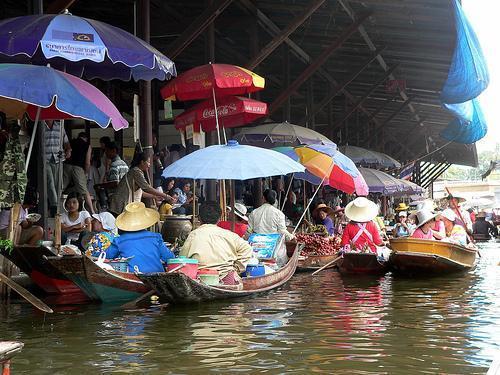How many zebras are in the picture?
Give a very brief answer. 0. 